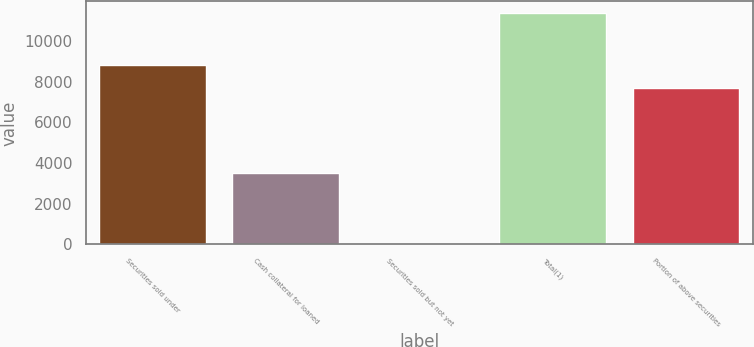<chart> <loc_0><loc_0><loc_500><loc_500><bar_chart><fcel>Securities sold under<fcel>Cash collateral for loaned<fcel>Securities sold but not yet<fcel>Total(1)<fcel>Portion of above securities<nl><fcel>8828.8<fcel>3496<fcel>2<fcel>11380<fcel>7691<nl></chart> 